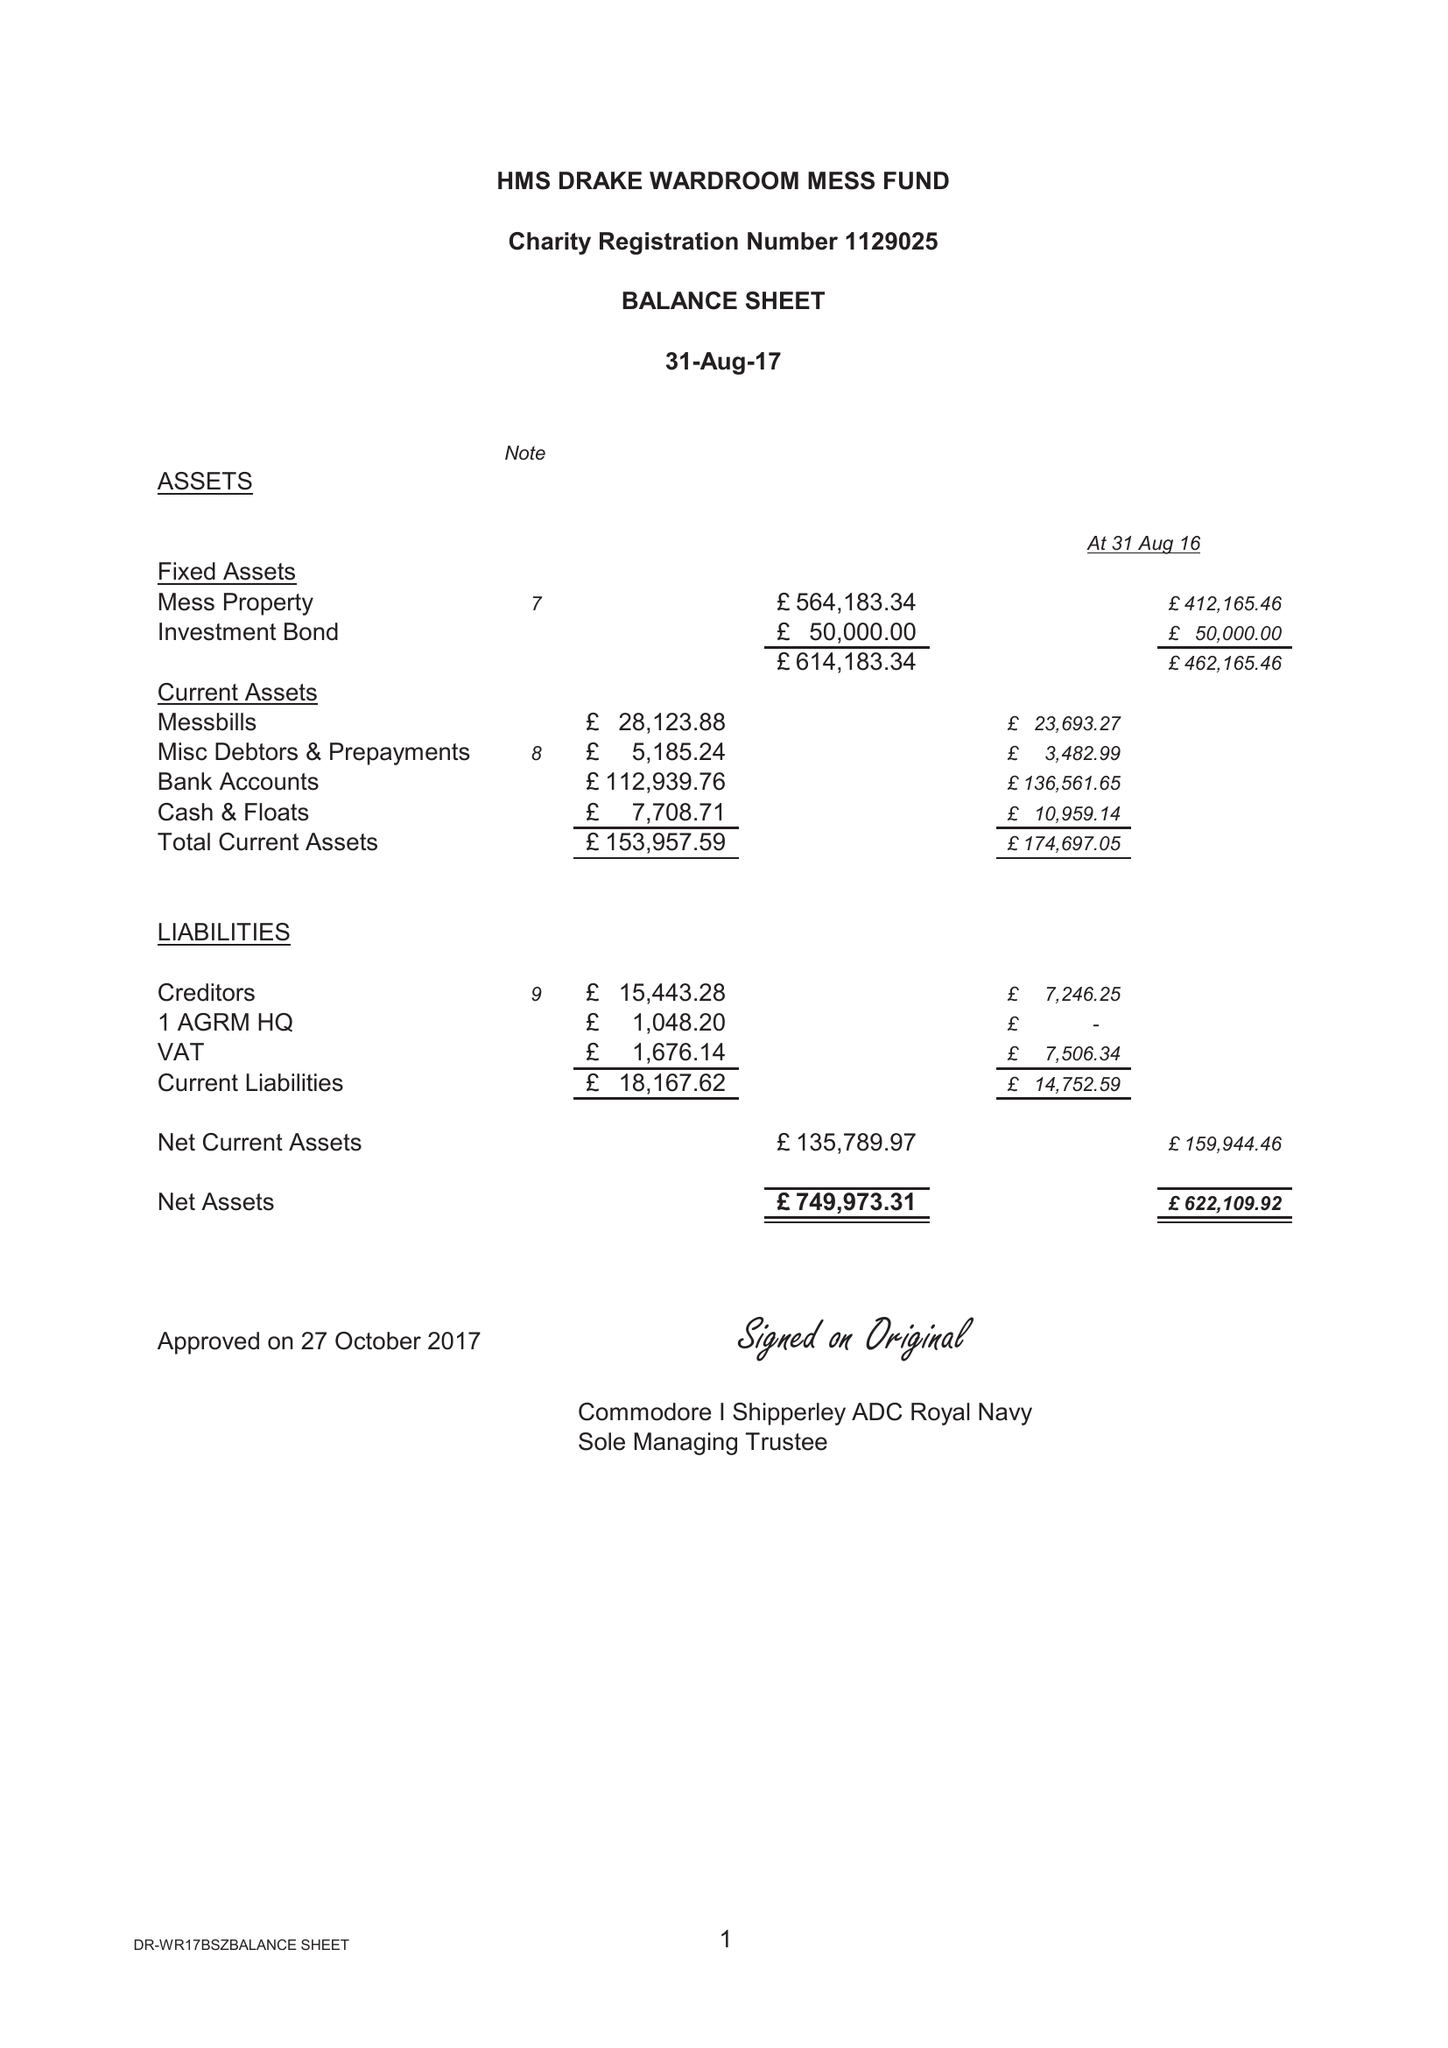What is the value for the charity_number?
Answer the question using a single word or phrase. 1129025 